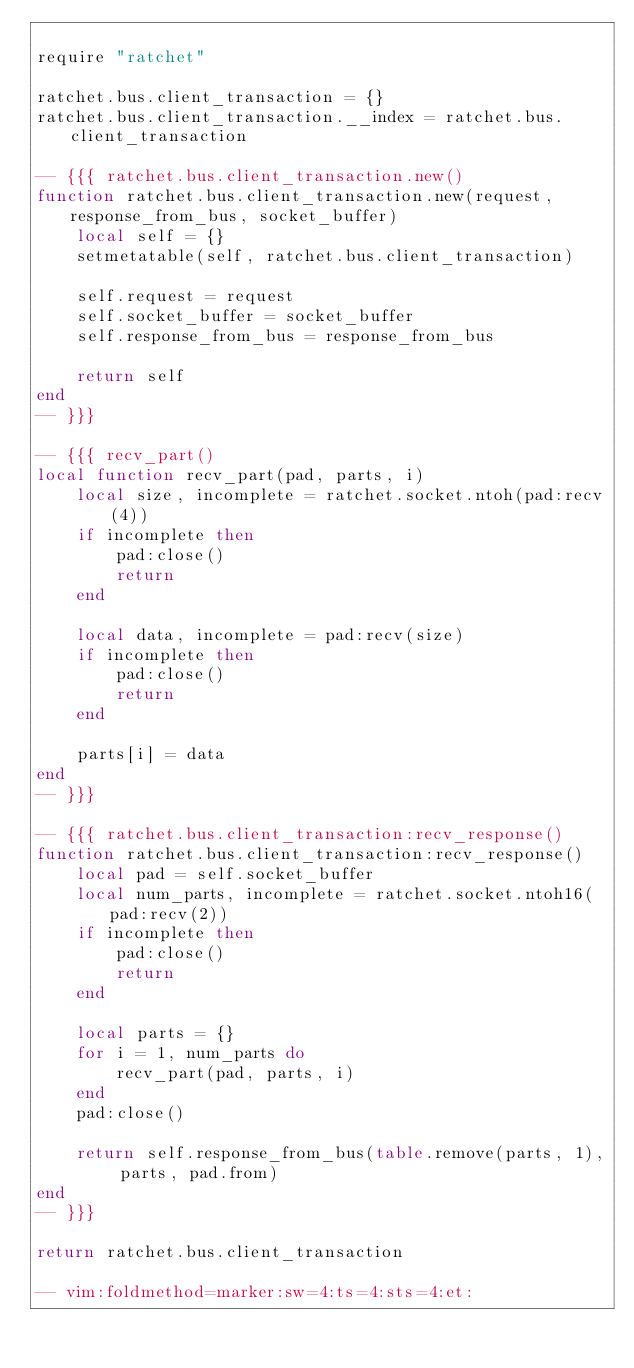<code> <loc_0><loc_0><loc_500><loc_500><_Lua_>
require "ratchet"

ratchet.bus.client_transaction = {}
ratchet.bus.client_transaction.__index = ratchet.bus.client_transaction

-- {{{ ratchet.bus.client_transaction.new()
function ratchet.bus.client_transaction.new(request, response_from_bus, socket_buffer)
    local self = {}
    setmetatable(self, ratchet.bus.client_transaction)

    self.request = request
    self.socket_buffer = socket_buffer
    self.response_from_bus = response_from_bus

    return self
end
-- }}}

-- {{{ recv_part()
local function recv_part(pad, parts, i)
    local size, incomplete = ratchet.socket.ntoh(pad:recv(4))
    if incomplete then
        pad:close()
        return
    end

    local data, incomplete = pad:recv(size)
    if incomplete then
        pad:close()
        return
    end

    parts[i] = data
end
-- }}}

-- {{{ ratchet.bus.client_transaction:recv_response()
function ratchet.bus.client_transaction:recv_response()
    local pad = self.socket_buffer
    local num_parts, incomplete = ratchet.socket.ntoh16(pad:recv(2))
    if incomplete then
        pad:close()
        return
    end

    local parts = {}
    for i = 1, num_parts do
        recv_part(pad, parts, i)
    end
    pad:close()

    return self.response_from_bus(table.remove(parts, 1), parts, pad.from)
end
-- }}}

return ratchet.bus.client_transaction

-- vim:foldmethod=marker:sw=4:ts=4:sts=4:et:
</code> 